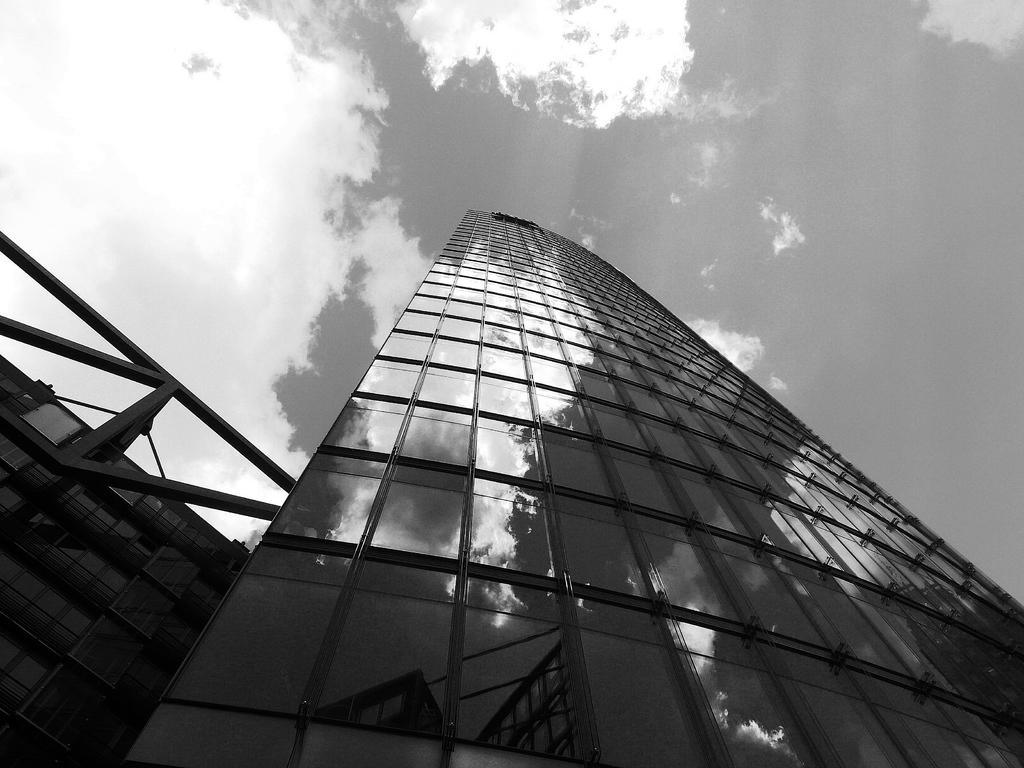Please provide a concise description of this image. In this image I can see few buildings in the front and in the background I can see clouds and the sky. I can also see this image is black and white in colour. 